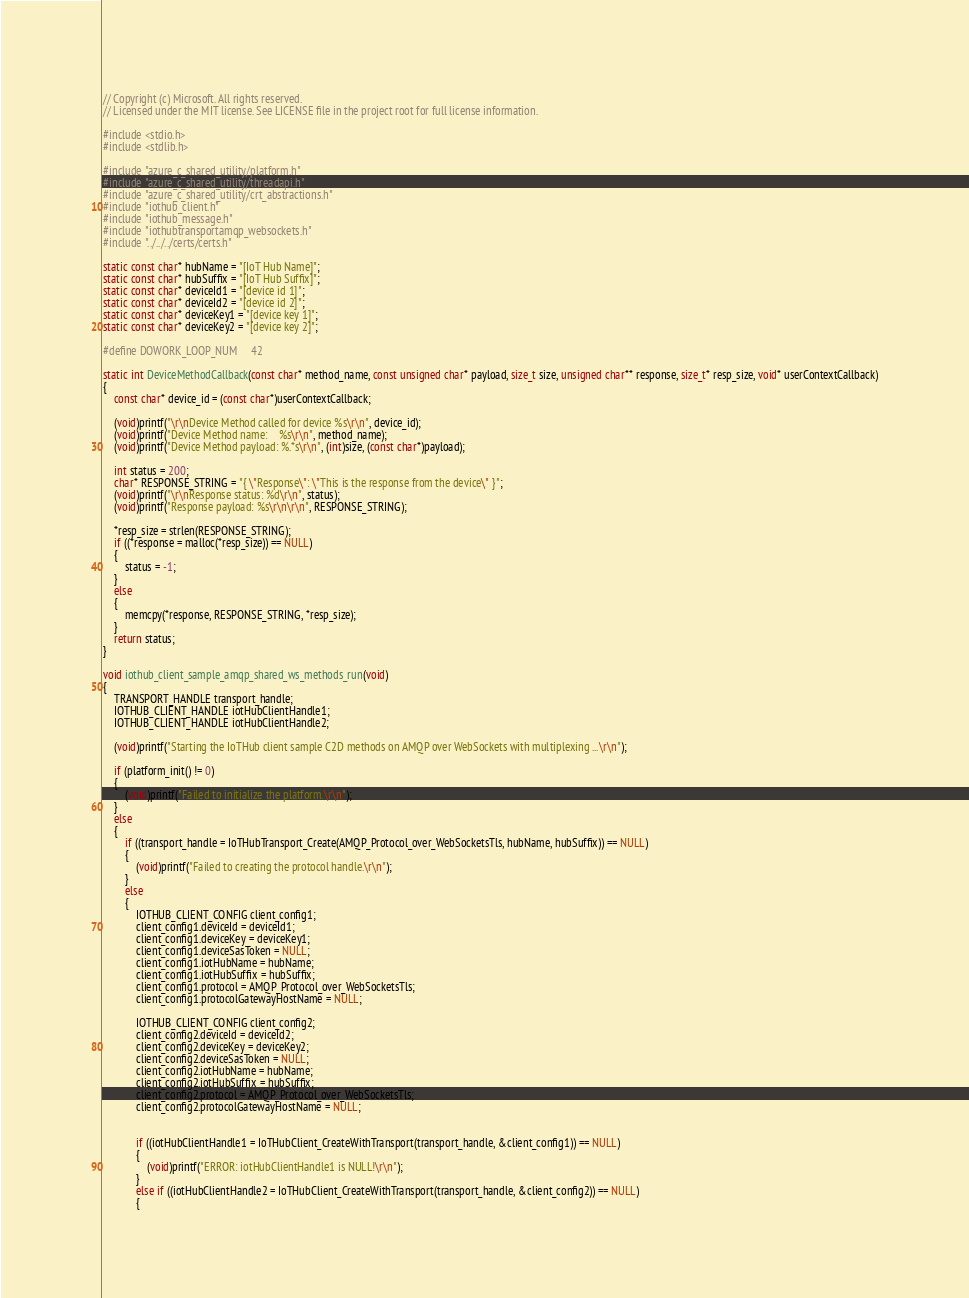Convert code to text. <code><loc_0><loc_0><loc_500><loc_500><_C_>// Copyright (c) Microsoft. All rights reserved.
// Licensed under the MIT license. See LICENSE file in the project root for full license information.

#include <stdio.h>
#include <stdlib.h>

#include "azure_c_shared_utility/platform.h"
#include "azure_c_shared_utility/threadapi.h"
#include "azure_c_shared_utility/crt_abstractions.h"
#include "iothub_client.h"
#include "iothub_message.h"
#include "iothubtransportamqp_websockets.h"
#include "../../../certs/certs.h"

static const char* hubName = "[IoT Hub Name]";
static const char* hubSuffix = "[IoT Hub Suffix]";
static const char* deviceId1 = "[device id 1]";
static const char* deviceId2 = "[device id 2]";
static const char* deviceKey1 = "[device key 1]";
static const char* deviceKey2 = "[device key 2]";

#define DOWORK_LOOP_NUM     42

static int DeviceMethodCallback(const char* method_name, const unsigned char* payload, size_t size, unsigned char** response, size_t* resp_size, void* userContextCallback)
{
	const char* device_id = (const char*)userContextCallback;

	(void)printf("\r\nDevice Method called for device %s\r\n", device_id);
	(void)printf("Device Method name:    %s\r\n", method_name);
	(void)printf("Device Method payload: %.*s\r\n", (int)size, (const char*)payload);

	int status = 200;
	char* RESPONSE_STRING = "{ \"Response\": \"This is the response from the device\" }";
	(void)printf("\r\nResponse status: %d\r\n", status);
	(void)printf("Response payload: %s\r\n\r\n", RESPONSE_STRING);

	*resp_size = strlen(RESPONSE_STRING);
	if ((*response = malloc(*resp_size)) == NULL)
	{
		status = -1;
	}
	else
	{
		memcpy(*response, RESPONSE_STRING, *resp_size);
	}
	return status;
}

void iothub_client_sample_amqp_shared_ws_methods_run(void)
{
	TRANSPORT_HANDLE transport_handle;
	IOTHUB_CLIENT_HANDLE iotHubClientHandle1;
	IOTHUB_CLIENT_HANDLE iotHubClientHandle2;

    (void)printf("Starting the IoTHub client sample C2D methods on AMQP over WebSockets with multiplexing ...\r\n");

    if (platform_init() != 0)
    {
        (void)printf("Failed to initialize the platform.\r\n");
    }
    else 
    {
        if ((transport_handle = IoTHubTransport_Create(AMQP_Protocol_over_WebSocketsTls, hubName, hubSuffix)) == NULL)
        {
            (void)printf("Failed to creating the protocol handle.\r\n");
        }
        else
        {
            IOTHUB_CLIENT_CONFIG client_config1;
            client_config1.deviceId = deviceId1;
            client_config1.deviceKey = deviceKey1;
            client_config1.deviceSasToken = NULL;
            client_config1.iotHubName = hubName;
            client_config1.iotHubSuffix = hubSuffix;
            client_config1.protocol = AMQP_Protocol_over_WebSocketsTls;
            client_config1.protocolGatewayHostName = NULL;

            IOTHUB_CLIENT_CONFIG client_config2;
            client_config2.deviceId = deviceId2;
            client_config2.deviceKey = deviceKey2;
            client_config2.deviceSasToken = NULL;
            client_config2.iotHubName = hubName;
            client_config2.iotHubSuffix = hubSuffix;
            client_config2.protocol = AMQP_Protocol_over_WebSocketsTls;
            client_config2.protocolGatewayHostName = NULL;

            
            if ((iotHubClientHandle1 = IoTHubClient_CreateWithTransport(transport_handle, &client_config1)) == NULL)
            {
                (void)printf("ERROR: iotHubClientHandle1 is NULL!\r\n");
            }
            else if ((iotHubClientHandle2 = IoTHubClient_CreateWithTransport(transport_handle, &client_config2)) == NULL)
            {</code> 